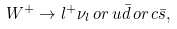<formula> <loc_0><loc_0><loc_500><loc_500>W ^ { + } \rightarrow l ^ { + } \nu _ { l } \, o r \, u \bar { d } \, o r \, c \bar { s } ,</formula> 